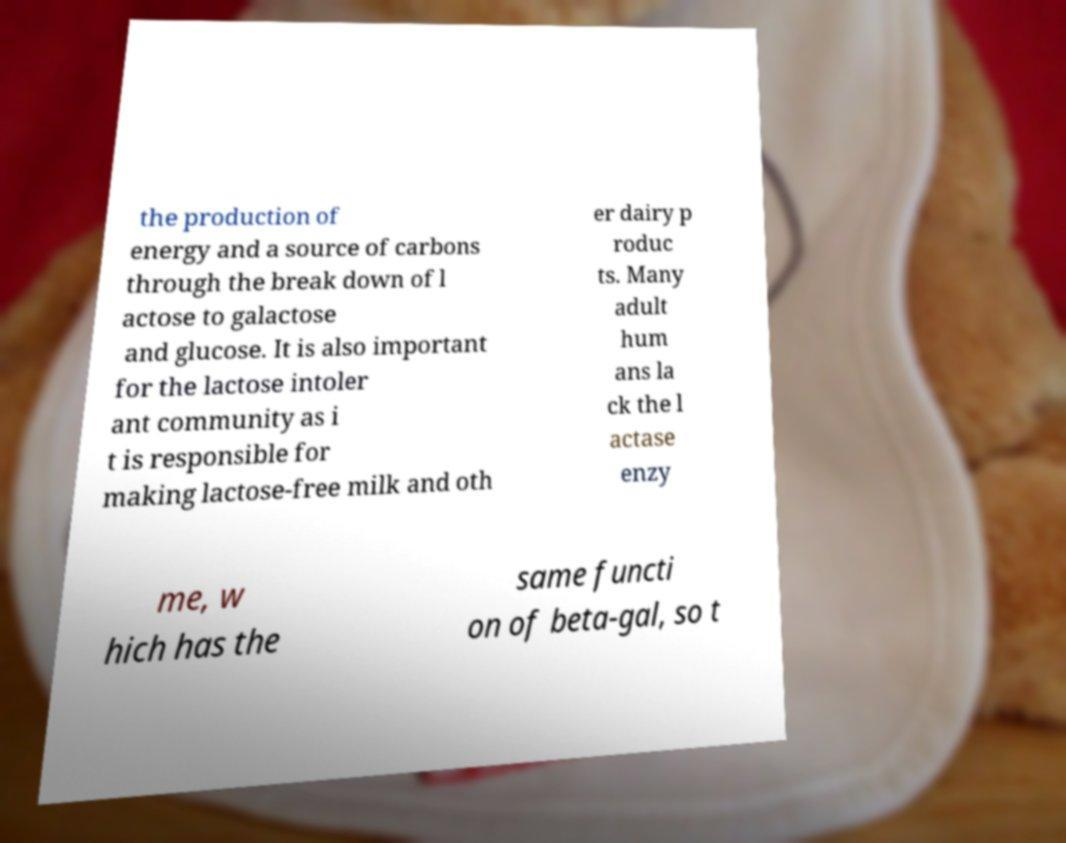Please identify and transcribe the text found in this image. the production of energy and a source of carbons through the break down of l actose to galactose and glucose. It is also important for the lactose intoler ant community as i t is responsible for making lactose-free milk and oth er dairy p roduc ts. Many adult hum ans la ck the l actase enzy me, w hich has the same functi on of beta-gal, so t 